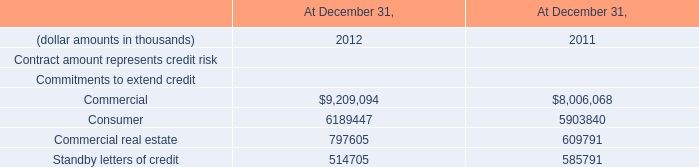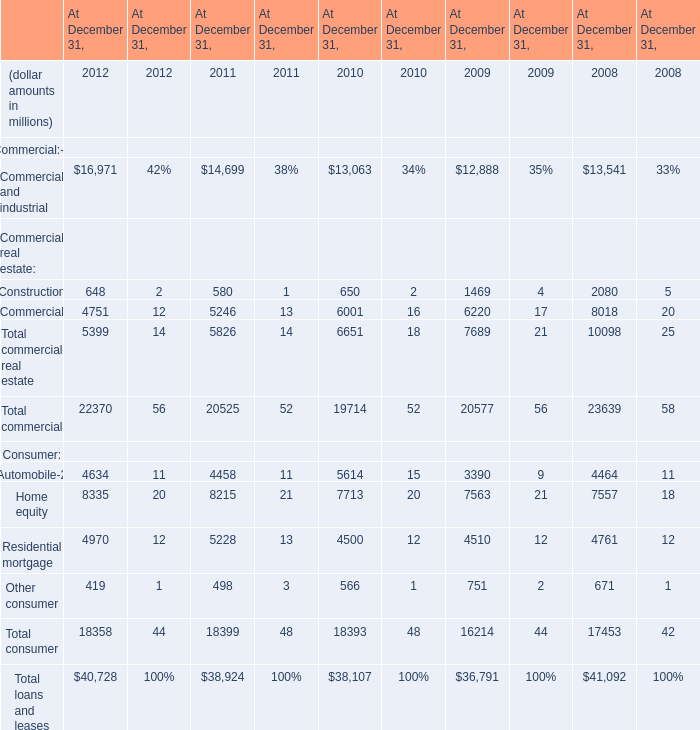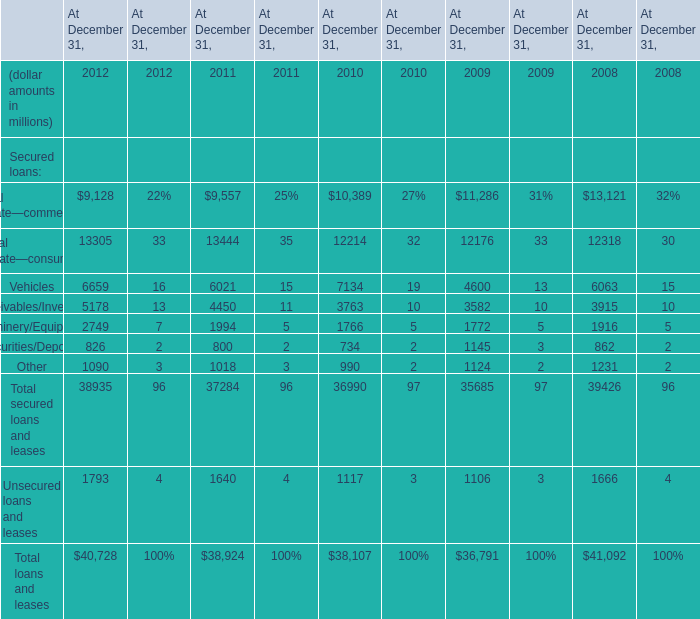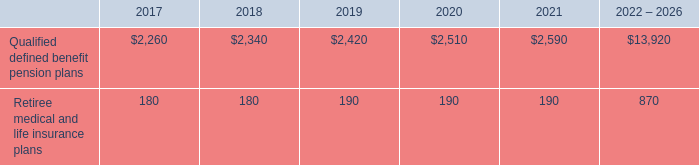What will Commercial and industrial be like in 2013 if it develops with the same increasing rate as current? (in million) 
Computations: (16971 * (1 + ((16971 - 14699) / 14699)))
Answer: 19594.17926. 